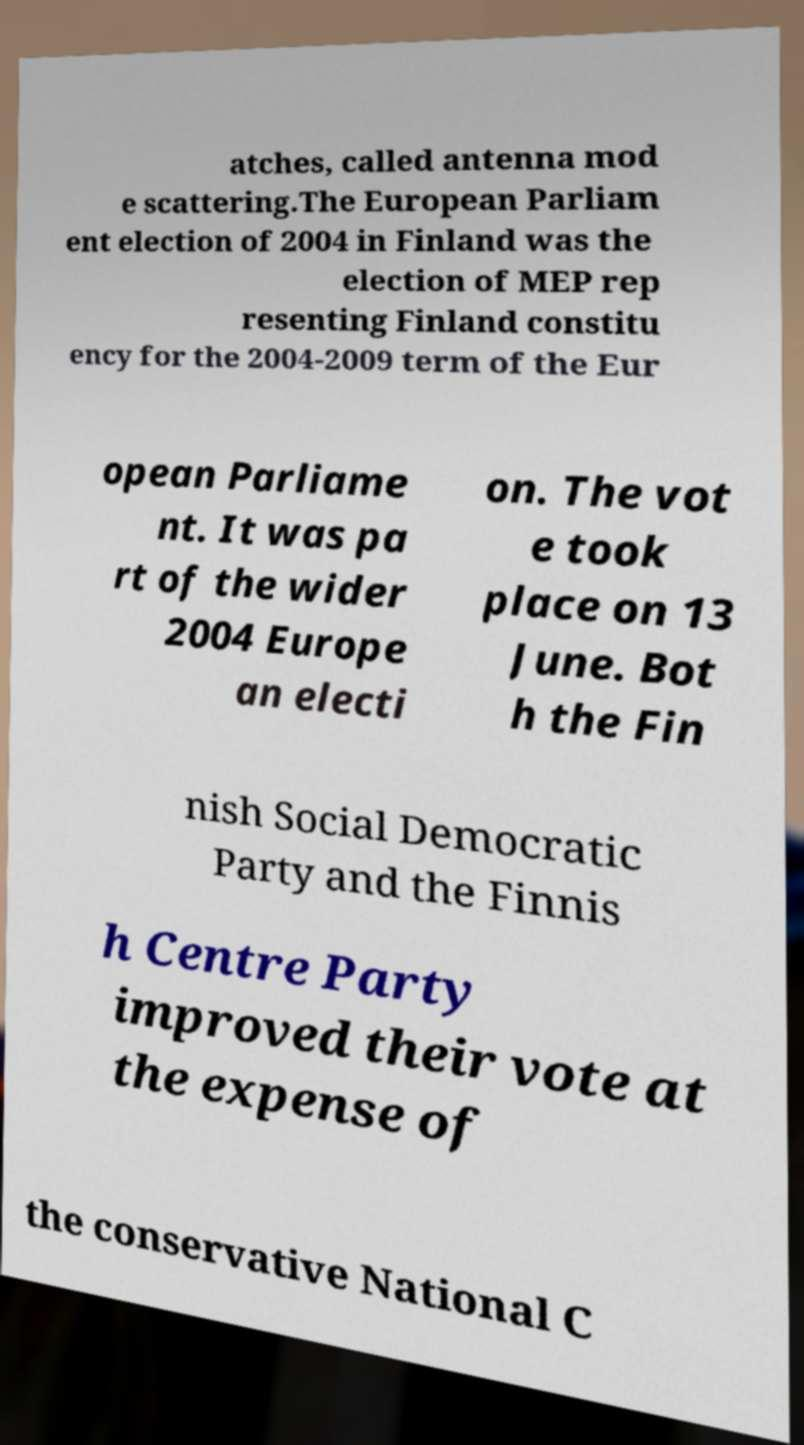There's text embedded in this image that I need extracted. Can you transcribe it verbatim? atches, called antenna mod e scattering.The European Parliam ent election of 2004 in Finland was the election of MEP rep resenting Finland constitu ency for the 2004-2009 term of the Eur opean Parliame nt. It was pa rt of the wider 2004 Europe an electi on. The vot e took place on 13 June. Bot h the Fin nish Social Democratic Party and the Finnis h Centre Party improved their vote at the expense of the conservative National C 